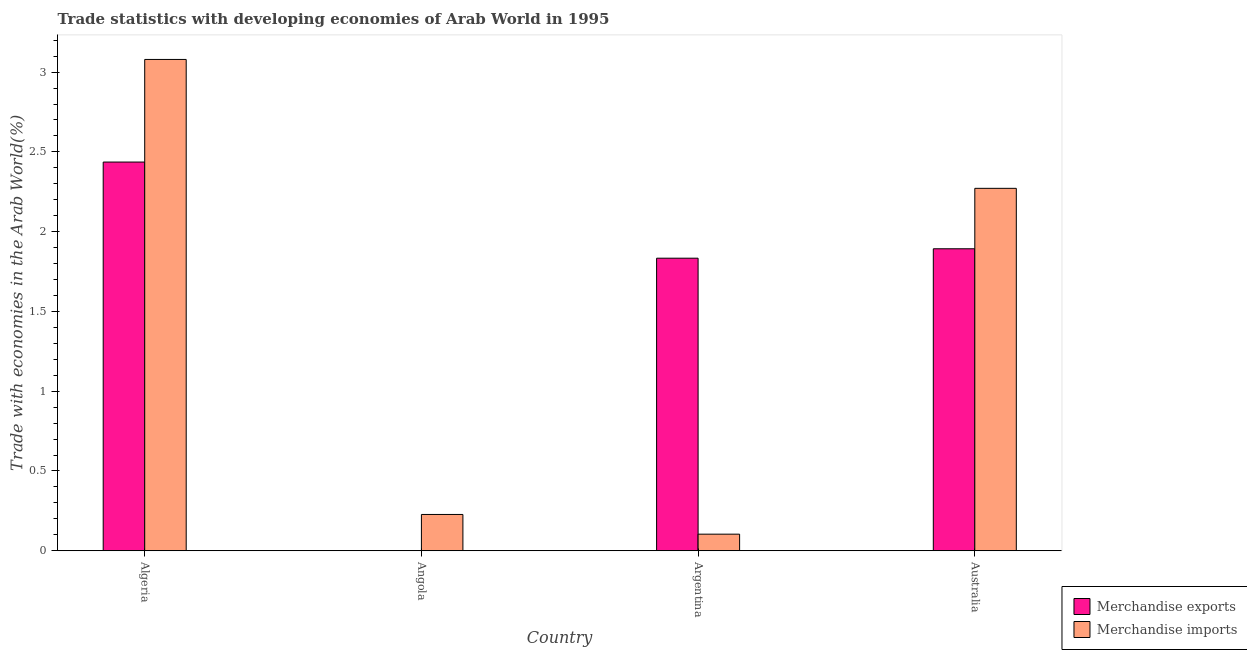How many groups of bars are there?
Offer a very short reply. 4. Are the number of bars on each tick of the X-axis equal?
Provide a succinct answer. Yes. How many bars are there on the 2nd tick from the right?
Your response must be concise. 2. What is the label of the 2nd group of bars from the left?
Make the answer very short. Angola. In how many cases, is the number of bars for a given country not equal to the number of legend labels?
Your answer should be very brief. 0. What is the merchandise imports in Australia?
Provide a succinct answer. 2.27. Across all countries, what is the maximum merchandise imports?
Keep it short and to the point. 3.08. Across all countries, what is the minimum merchandise exports?
Offer a very short reply. 0. In which country was the merchandise imports maximum?
Your answer should be compact. Algeria. In which country was the merchandise exports minimum?
Your response must be concise. Angola. What is the total merchandise imports in the graph?
Keep it short and to the point. 5.68. What is the difference between the merchandise imports in Argentina and that in Australia?
Offer a very short reply. -2.17. What is the difference between the merchandise exports in Australia and the merchandise imports in Angola?
Provide a short and direct response. 1.67. What is the average merchandise imports per country?
Your answer should be compact. 1.42. What is the difference between the merchandise imports and merchandise exports in Algeria?
Your answer should be compact. 0.64. In how many countries, is the merchandise exports greater than 0.8 %?
Your answer should be compact. 3. What is the ratio of the merchandise imports in Angola to that in Argentina?
Offer a very short reply. 2.19. Is the difference between the merchandise exports in Angola and Argentina greater than the difference between the merchandise imports in Angola and Argentina?
Give a very brief answer. No. What is the difference between the highest and the second highest merchandise exports?
Make the answer very short. 0.54. What is the difference between the highest and the lowest merchandise exports?
Keep it short and to the point. 2.43. Is the sum of the merchandise imports in Angola and Argentina greater than the maximum merchandise exports across all countries?
Your answer should be compact. No. What does the 2nd bar from the right in Argentina represents?
Offer a terse response. Merchandise exports. How many countries are there in the graph?
Your answer should be compact. 4. What is the difference between two consecutive major ticks on the Y-axis?
Ensure brevity in your answer.  0.5. Does the graph contain grids?
Make the answer very short. No. How are the legend labels stacked?
Ensure brevity in your answer.  Vertical. What is the title of the graph?
Your answer should be compact. Trade statistics with developing economies of Arab World in 1995. Does "Services" appear as one of the legend labels in the graph?
Give a very brief answer. No. What is the label or title of the X-axis?
Make the answer very short. Country. What is the label or title of the Y-axis?
Provide a short and direct response. Trade with economies in the Arab World(%). What is the Trade with economies in the Arab World(%) in Merchandise exports in Algeria?
Your response must be concise. 2.44. What is the Trade with economies in the Arab World(%) in Merchandise imports in Algeria?
Provide a succinct answer. 3.08. What is the Trade with economies in the Arab World(%) of Merchandise exports in Angola?
Offer a terse response. 0. What is the Trade with economies in the Arab World(%) in Merchandise imports in Angola?
Keep it short and to the point. 0.23. What is the Trade with economies in the Arab World(%) of Merchandise exports in Argentina?
Your response must be concise. 1.83. What is the Trade with economies in the Arab World(%) of Merchandise imports in Argentina?
Provide a short and direct response. 0.1. What is the Trade with economies in the Arab World(%) of Merchandise exports in Australia?
Your response must be concise. 1.89. What is the Trade with economies in the Arab World(%) of Merchandise imports in Australia?
Offer a terse response. 2.27. Across all countries, what is the maximum Trade with economies in the Arab World(%) in Merchandise exports?
Provide a succinct answer. 2.44. Across all countries, what is the maximum Trade with economies in the Arab World(%) in Merchandise imports?
Give a very brief answer. 3.08. Across all countries, what is the minimum Trade with economies in the Arab World(%) of Merchandise exports?
Make the answer very short. 0. Across all countries, what is the minimum Trade with economies in the Arab World(%) of Merchandise imports?
Keep it short and to the point. 0.1. What is the total Trade with economies in the Arab World(%) of Merchandise exports in the graph?
Make the answer very short. 6.16. What is the total Trade with economies in the Arab World(%) of Merchandise imports in the graph?
Offer a terse response. 5.68. What is the difference between the Trade with economies in the Arab World(%) of Merchandise exports in Algeria and that in Angola?
Keep it short and to the point. 2.43. What is the difference between the Trade with economies in the Arab World(%) of Merchandise imports in Algeria and that in Angola?
Give a very brief answer. 2.85. What is the difference between the Trade with economies in the Arab World(%) of Merchandise exports in Algeria and that in Argentina?
Your answer should be compact. 0.6. What is the difference between the Trade with economies in the Arab World(%) of Merchandise imports in Algeria and that in Argentina?
Ensure brevity in your answer.  2.98. What is the difference between the Trade with economies in the Arab World(%) in Merchandise exports in Algeria and that in Australia?
Provide a succinct answer. 0.54. What is the difference between the Trade with economies in the Arab World(%) of Merchandise imports in Algeria and that in Australia?
Your answer should be compact. 0.81. What is the difference between the Trade with economies in the Arab World(%) in Merchandise exports in Angola and that in Argentina?
Keep it short and to the point. -1.83. What is the difference between the Trade with economies in the Arab World(%) in Merchandise imports in Angola and that in Argentina?
Offer a very short reply. 0.12. What is the difference between the Trade with economies in the Arab World(%) of Merchandise exports in Angola and that in Australia?
Make the answer very short. -1.89. What is the difference between the Trade with economies in the Arab World(%) of Merchandise imports in Angola and that in Australia?
Your answer should be very brief. -2.04. What is the difference between the Trade with economies in the Arab World(%) of Merchandise exports in Argentina and that in Australia?
Provide a succinct answer. -0.06. What is the difference between the Trade with economies in the Arab World(%) in Merchandise imports in Argentina and that in Australia?
Give a very brief answer. -2.17. What is the difference between the Trade with economies in the Arab World(%) in Merchandise exports in Algeria and the Trade with economies in the Arab World(%) in Merchandise imports in Angola?
Ensure brevity in your answer.  2.21. What is the difference between the Trade with economies in the Arab World(%) in Merchandise exports in Algeria and the Trade with economies in the Arab World(%) in Merchandise imports in Argentina?
Offer a terse response. 2.33. What is the difference between the Trade with economies in the Arab World(%) in Merchandise exports in Algeria and the Trade with economies in the Arab World(%) in Merchandise imports in Australia?
Make the answer very short. 0.16. What is the difference between the Trade with economies in the Arab World(%) of Merchandise exports in Angola and the Trade with economies in the Arab World(%) of Merchandise imports in Argentina?
Your response must be concise. -0.1. What is the difference between the Trade with economies in the Arab World(%) of Merchandise exports in Angola and the Trade with economies in the Arab World(%) of Merchandise imports in Australia?
Your response must be concise. -2.27. What is the difference between the Trade with economies in the Arab World(%) in Merchandise exports in Argentina and the Trade with economies in the Arab World(%) in Merchandise imports in Australia?
Provide a succinct answer. -0.44. What is the average Trade with economies in the Arab World(%) of Merchandise exports per country?
Your answer should be very brief. 1.54. What is the average Trade with economies in the Arab World(%) in Merchandise imports per country?
Keep it short and to the point. 1.42. What is the difference between the Trade with economies in the Arab World(%) of Merchandise exports and Trade with economies in the Arab World(%) of Merchandise imports in Algeria?
Ensure brevity in your answer.  -0.64. What is the difference between the Trade with economies in the Arab World(%) of Merchandise exports and Trade with economies in the Arab World(%) of Merchandise imports in Angola?
Your answer should be very brief. -0.23. What is the difference between the Trade with economies in the Arab World(%) of Merchandise exports and Trade with economies in the Arab World(%) of Merchandise imports in Argentina?
Your answer should be very brief. 1.73. What is the difference between the Trade with economies in the Arab World(%) of Merchandise exports and Trade with economies in the Arab World(%) of Merchandise imports in Australia?
Offer a very short reply. -0.38. What is the ratio of the Trade with economies in the Arab World(%) in Merchandise exports in Algeria to that in Angola?
Your answer should be compact. 1668.72. What is the ratio of the Trade with economies in the Arab World(%) in Merchandise imports in Algeria to that in Angola?
Provide a short and direct response. 13.53. What is the ratio of the Trade with economies in the Arab World(%) of Merchandise exports in Algeria to that in Argentina?
Offer a very short reply. 1.33. What is the ratio of the Trade with economies in the Arab World(%) in Merchandise imports in Algeria to that in Argentina?
Offer a terse response. 29.59. What is the ratio of the Trade with economies in the Arab World(%) in Merchandise exports in Algeria to that in Australia?
Your response must be concise. 1.29. What is the ratio of the Trade with economies in the Arab World(%) of Merchandise imports in Algeria to that in Australia?
Provide a succinct answer. 1.36. What is the ratio of the Trade with economies in the Arab World(%) of Merchandise exports in Angola to that in Argentina?
Make the answer very short. 0. What is the ratio of the Trade with economies in the Arab World(%) in Merchandise imports in Angola to that in Argentina?
Provide a succinct answer. 2.19. What is the ratio of the Trade with economies in the Arab World(%) of Merchandise exports in Angola to that in Australia?
Give a very brief answer. 0. What is the ratio of the Trade with economies in the Arab World(%) in Merchandise imports in Angola to that in Australia?
Your answer should be very brief. 0.1. What is the ratio of the Trade with economies in the Arab World(%) in Merchandise exports in Argentina to that in Australia?
Your response must be concise. 0.97. What is the ratio of the Trade with economies in the Arab World(%) in Merchandise imports in Argentina to that in Australia?
Provide a succinct answer. 0.05. What is the difference between the highest and the second highest Trade with economies in the Arab World(%) in Merchandise exports?
Provide a short and direct response. 0.54. What is the difference between the highest and the second highest Trade with economies in the Arab World(%) of Merchandise imports?
Your answer should be very brief. 0.81. What is the difference between the highest and the lowest Trade with economies in the Arab World(%) in Merchandise exports?
Your answer should be compact. 2.43. What is the difference between the highest and the lowest Trade with economies in the Arab World(%) of Merchandise imports?
Provide a short and direct response. 2.98. 